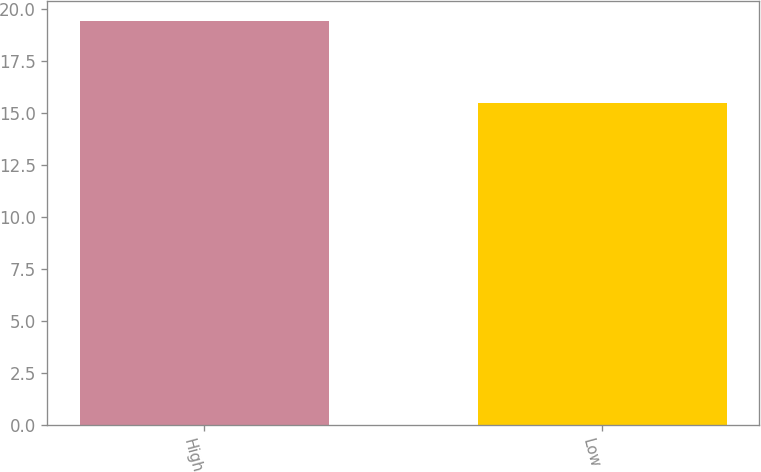Convert chart to OTSL. <chart><loc_0><loc_0><loc_500><loc_500><bar_chart><fcel>High<fcel>Low<nl><fcel>19.39<fcel>15.45<nl></chart> 